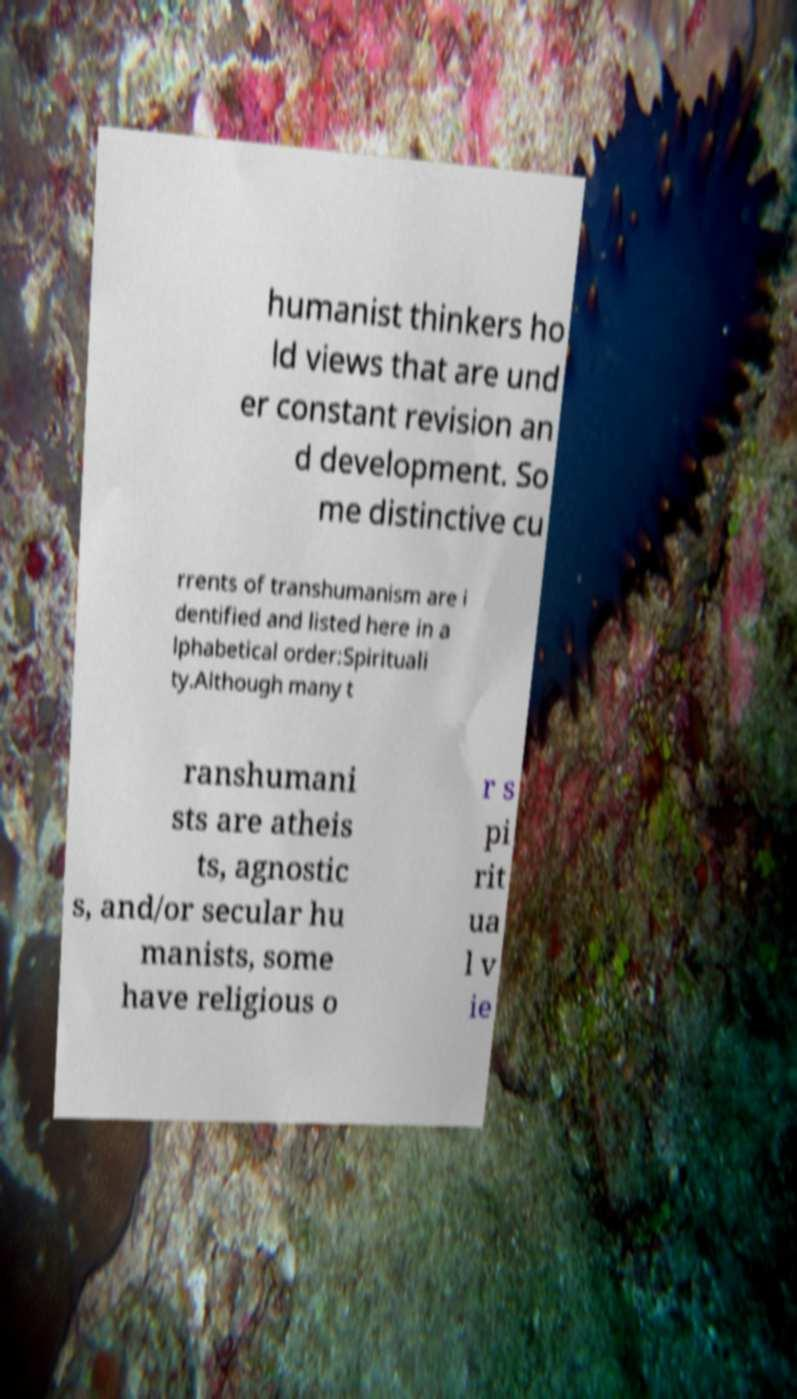What messages or text are displayed in this image? I need them in a readable, typed format. humanist thinkers ho ld views that are und er constant revision an d development. So me distinctive cu rrents of transhumanism are i dentified and listed here in a lphabetical order:Spirituali ty.Although many t ranshumani sts are atheis ts, agnostic s, and/or secular hu manists, some have religious o r s pi rit ua l v ie 